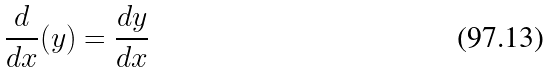Convert formula to latex. <formula><loc_0><loc_0><loc_500><loc_500>\frac { d } { d x } ( y ) = \frac { d y } { d x }</formula> 